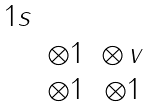Convert formula to latex. <formula><loc_0><loc_0><loc_500><loc_500>\begin{matrix} 1 s & & \\ & \otimes 1 & \otimes \, v \\ & \otimes 1 & \otimes 1 \end{matrix}</formula> 